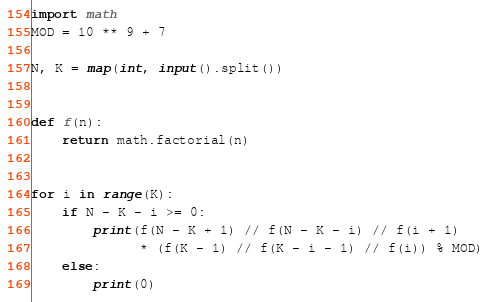Convert code to text. <code><loc_0><loc_0><loc_500><loc_500><_Python_>import math
MOD = 10 ** 9 + 7

N, K = map(int, input().split())


def f(n):
    return math.factorial(n)


for i in range(K):
    if N - K - i >= 0:
        print(f(N - K + 1) // f(N - K - i) // f(i + 1)
              * (f(K - 1) // f(K - i - 1) // f(i)) % MOD)
    else:
        print(0)
</code> 